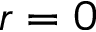<formula> <loc_0><loc_0><loc_500><loc_500>r = 0</formula> 